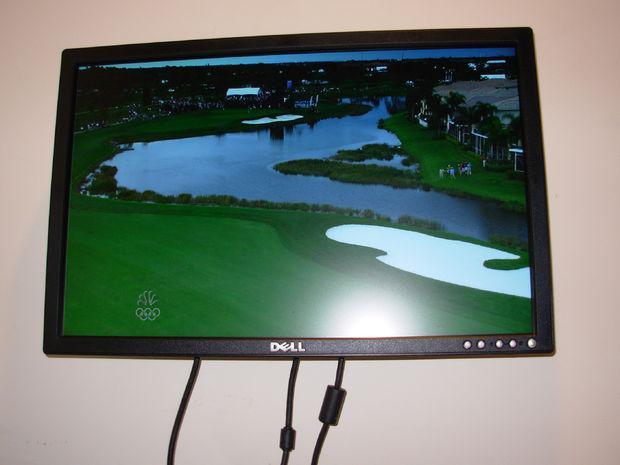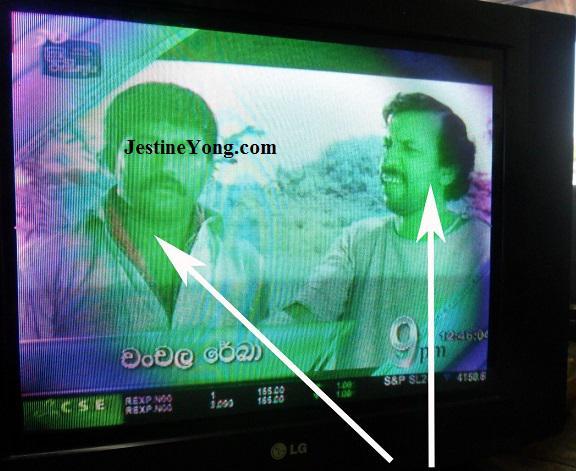The first image is the image on the left, the second image is the image on the right. For the images displayed, is the sentence "One of the images features a television displaying a hummingbird next to a flower." factually correct? Answer yes or no. No. The first image is the image on the left, the second image is the image on the right. Considering the images on both sides, is "In at least one image there is a television with a blue flower and a single hummingbird drinking from it." valid? Answer yes or no. No. 